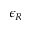<formula> <loc_0><loc_0><loc_500><loc_500>\epsilon _ { R }</formula> 